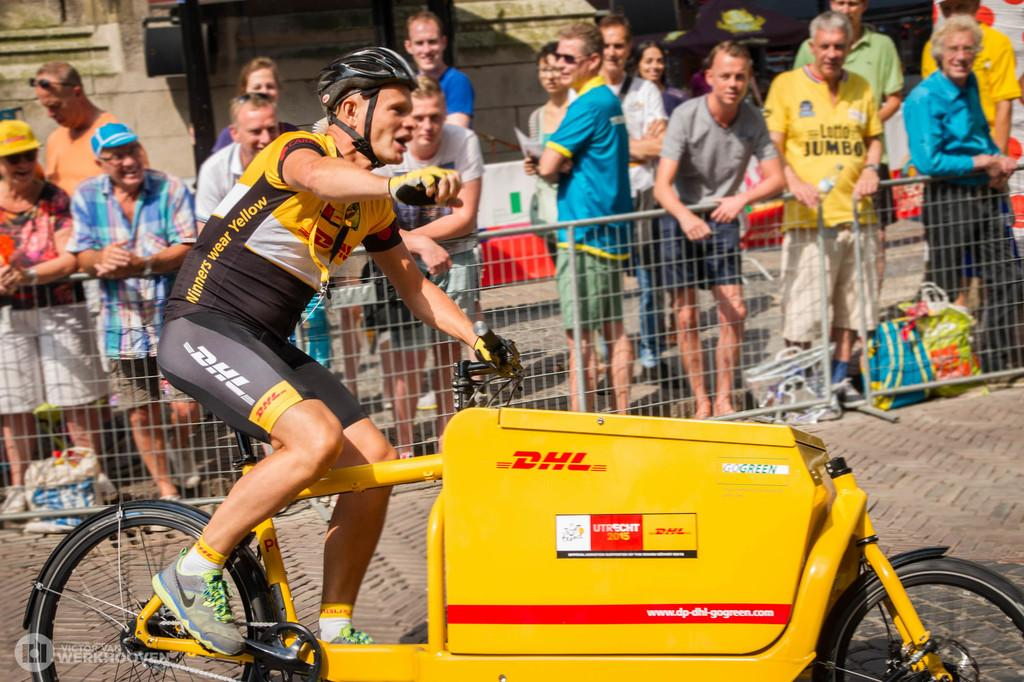What is the person in the image doing? The person is riding a bicycle in the image. What protective gear is the person wearing? The person is wearing a helmet and gloves. Can you describe the people in the background? The people are standing on the other side of a railing in the background. What is the person on the bicycle likely doing? The person is likely riding the bicycle for transportation or recreation. What type of silk fabric is draped over the skate in the image? There is no skate or silk fabric present in the image. 